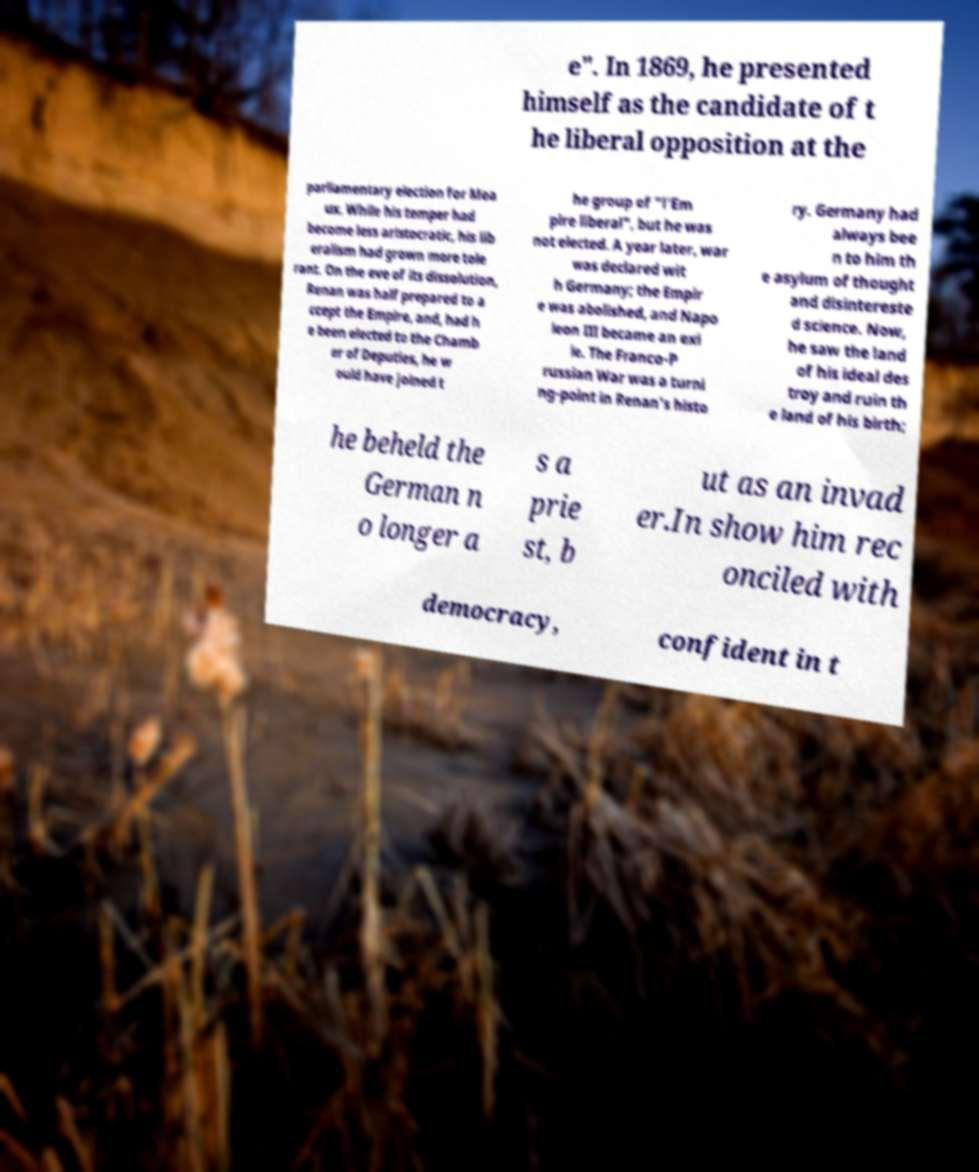Please read and relay the text visible in this image. What does it say? e". In 1869, he presented himself as the candidate of t he liberal opposition at the parliamentary election for Mea ux. While his temper had become less aristocratic, his lib eralism had grown more tole rant. On the eve of its dissolution, Renan was half prepared to a ccept the Empire, and, had h e been elected to the Chamb er of Deputies, he w ould have joined t he group of "l'Em pire liberal", but he was not elected. A year later, war was declared wit h Germany; the Empir e was abolished, and Napo leon III became an exi le. The Franco-P russian War was a turni ng-point in Renan's histo ry. Germany had always bee n to him th e asylum of thought and disintereste d science. Now, he saw the land of his ideal des troy and ruin th e land of his birth; he beheld the German n o longer a s a prie st, b ut as an invad er.In show him rec onciled with democracy, confident in t 